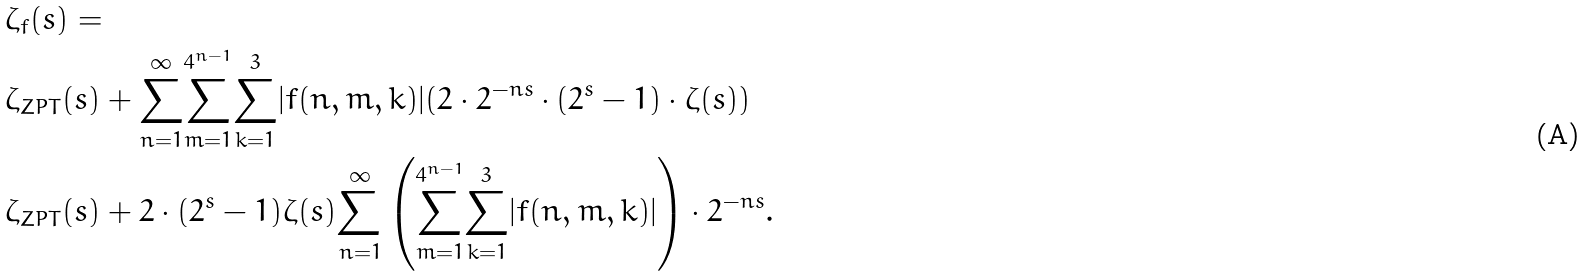<formula> <loc_0><loc_0><loc_500><loc_500>& \zeta _ { f } ( s ) = \\ & \zeta _ { Z P T } ( s ) + \underset { n = 1 } { \overset { \infty } { \sum } } \underset { m = 1 } { \overset { 4 ^ { n - 1 } } { \sum } } \underset { k = 1 } { \overset { 3 } { \sum } } | f ( n , m , k ) | ( 2 \cdot 2 ^ { - n s } \cdot ( 2 ^ { s } - 1 ) \cdot \zeta ( s ) ) \\ & \zeta _ { Z P T } ( s ) + 2 \cdot ( 2 ^ { s } - 1 ) \zeta ( s ) \underset { n = 1 } { \overset { \infty } { \sum } } \left ( \underset { m = 1 } { \overset { 4 ^ { n - 1 } } { \sum } } \underset { k = 1 } { \overset { 3 } { \sum } } | f ( n , m , k ) | \right ) \cdot 2 ^ { - n s } .</formula> 